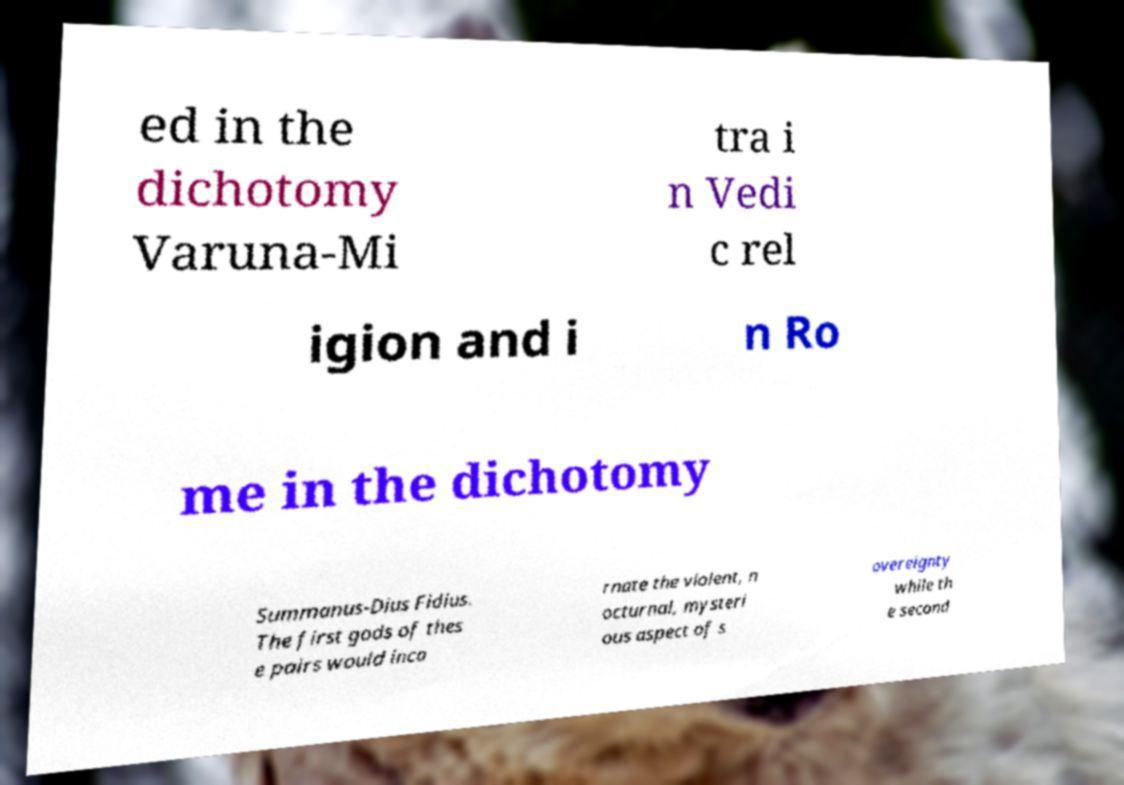Could you assist in decoding the text presented in this image and type it out clearly? ed in the dichotomy Varuna-Mi tra i n Vedi c rel igion and i n Ro me in the dichotomy Summanus-Dius Fidius. The first gods of thes e pairs would inca rnate the violent, n octurnal, mysteri ous aspect of s overeignty while th e second 